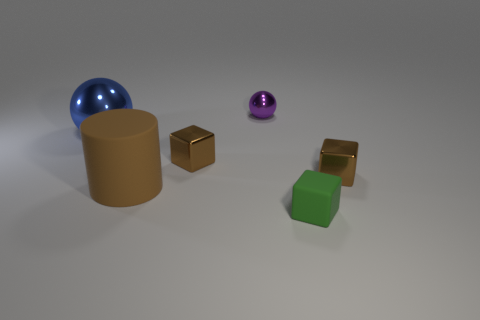Add 1 purple objects. How many objects exist? 7 Subtract all cylinders. How many objects are left? 5 Add 2 large brown rubber things. How many large brown rubber things are left? 3 Add 5 rubber cylinders. How many rubber cylinders exist? 6 Subtract 0 blue blocks. How many objects are left? 6 Subtract all tiny rubber balls. Subtract all blue shiny objects. How many objects are left? 5 